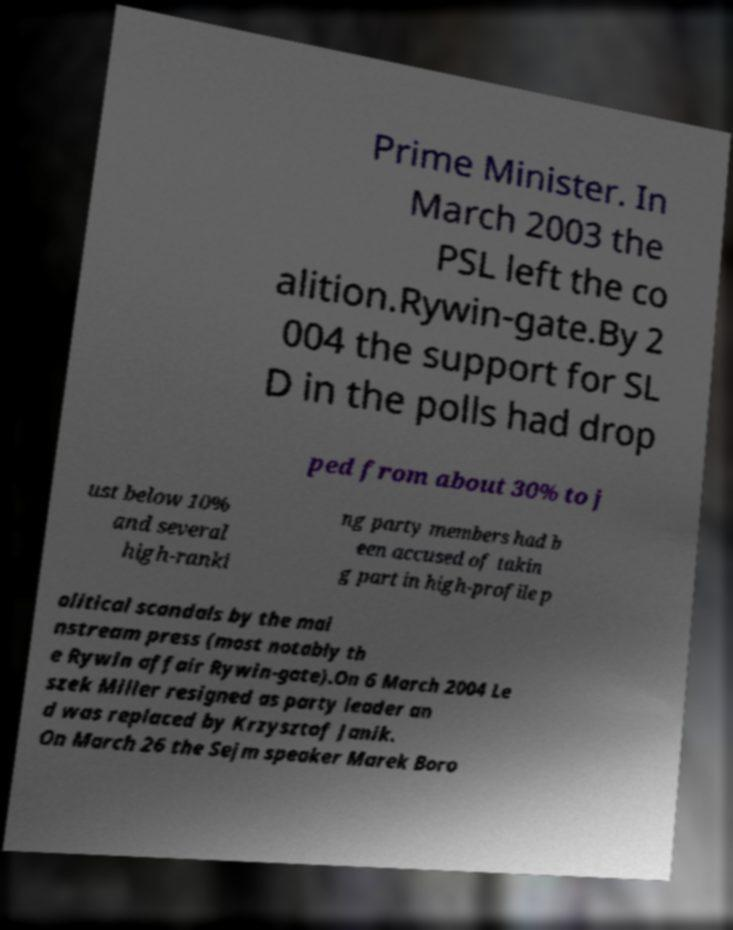Can you accurately transcribe the text from the provided image for me? Prime Minister. In March 2003 the PSL left the co alition.Rywin-gate.By 2 004 the support for SL D in the polls had drop ped from about 30% to j ust below 10% and several high-ranki ng party members had b een accused of takin g part in high-profile p olitical scandals by the mai nstream press (most notably th e Rywin affair Rywin-gate).On 6 March 2004 Le szek Miller resigned as party leader an d was replaced by Krzysztof Janik. On March 26 the Sejm speaker Marek Boro 